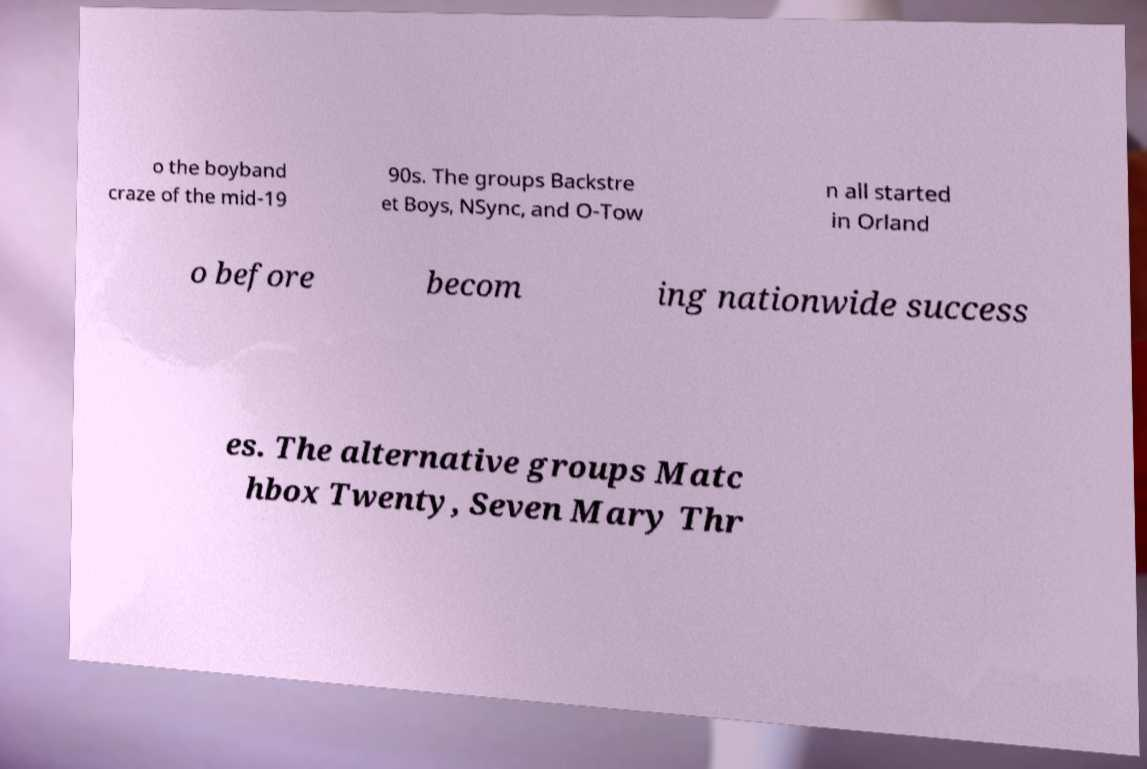Could you assist in decoding the text presented in this image and type it out clearly? o the boyband craze of the mid-19 90s. The groups Backstre et Boys, NSync, and O-Tow n all started in Orland o before becom ing nationwide success es. The alternative groups Matc hbox Twenty, Seven Mary Thr 